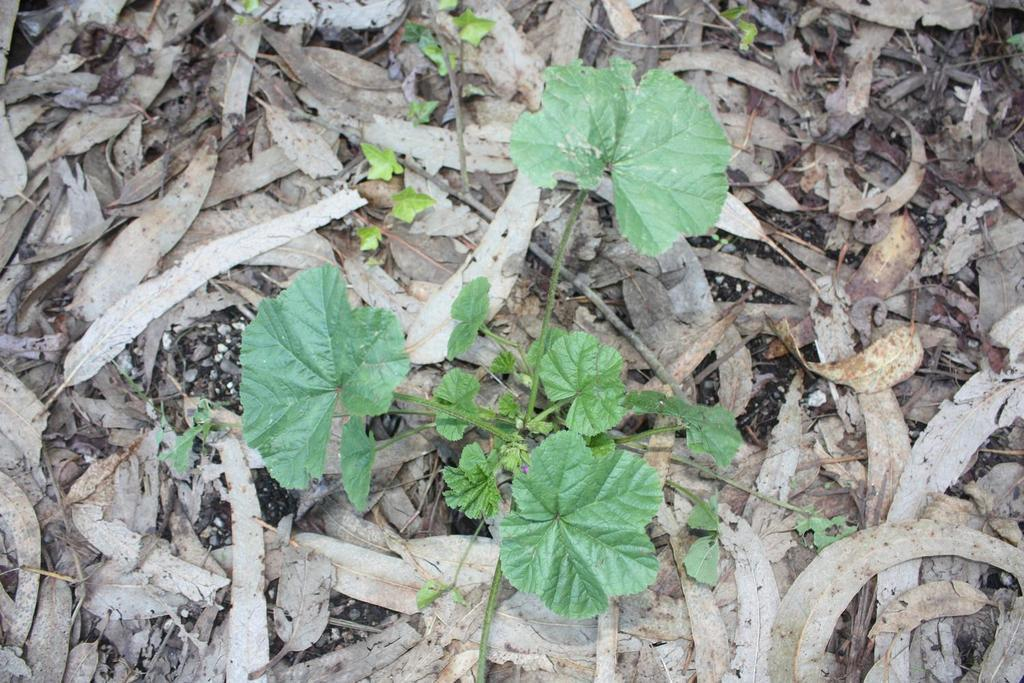What type of natural elements can be seen in the image? There are dry leaves in the image. What other living organisms are present in the image? There are small plants in the image. What is the color of the plants in the image? The plants are green in color. How many slaves are visible in the image? There are no slaves present in the image. What type of animals can be seen in the image? There are no animals, such as horses, present in the image. 